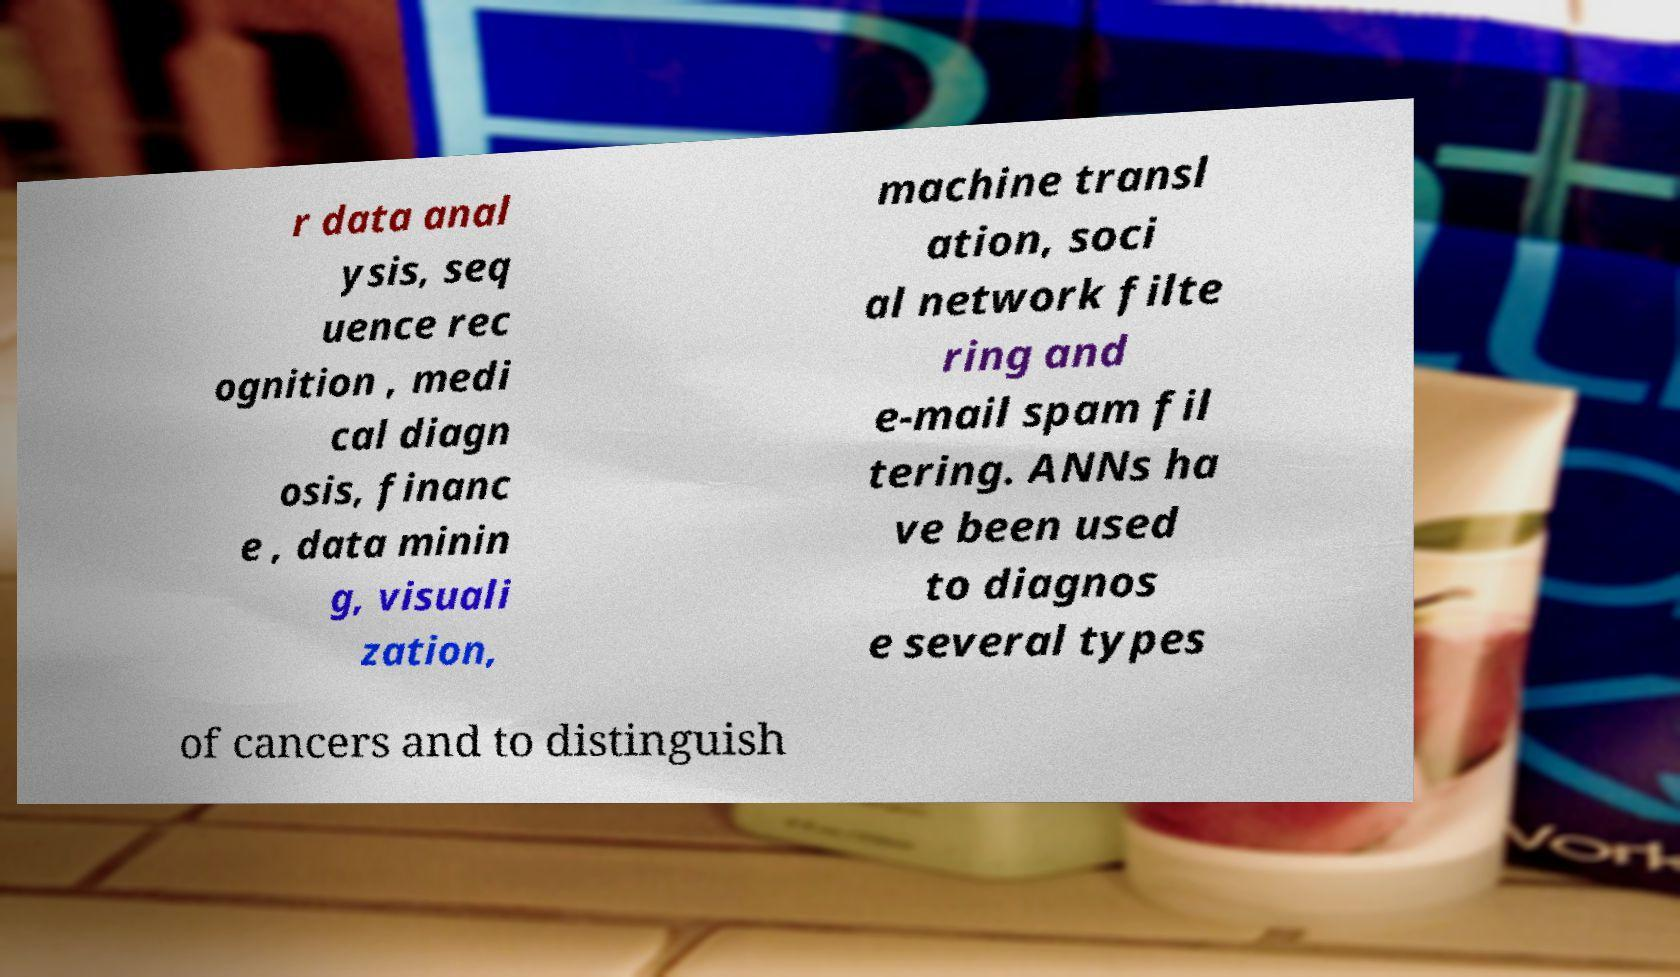Can you accurately transcribe the text from the provided image for me? r data anal ysis, seq uence rec ognition , medi cal diagn osis, financ e , data minin g, visuali zation, machine transl ation, soci al network filte ring and e-mail spam fil tering. ANNs ha ve been used to diagnos e several types of cancers and to distinguish 